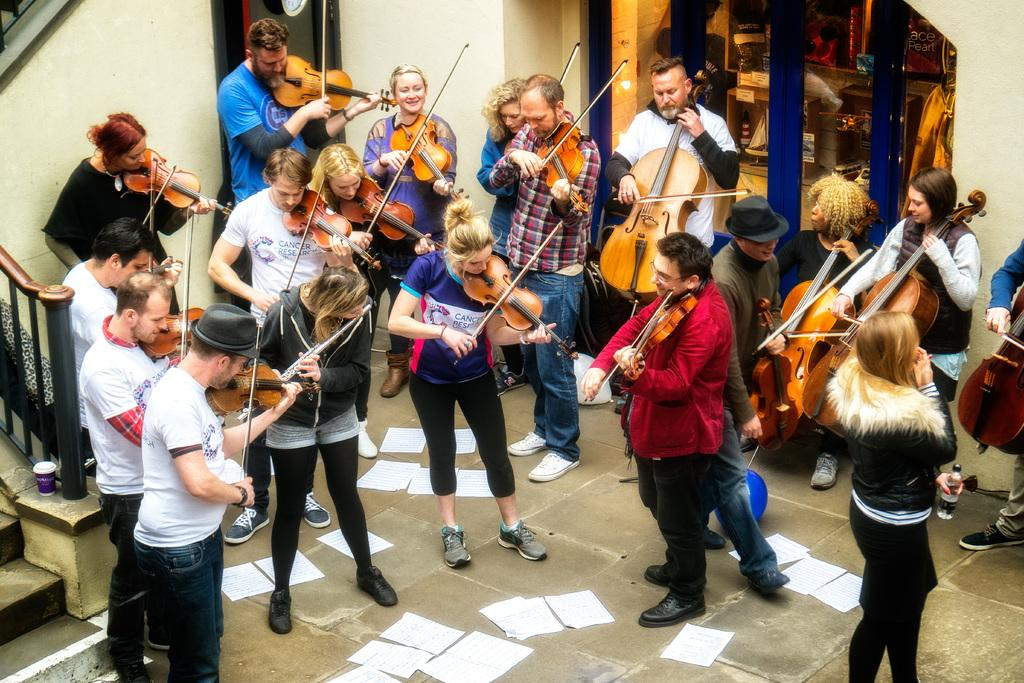What are the people in the image doing? The people in the image are playing violins. What objects are the people using to play music? The people are using violins to play music. Are there any additional items on the ground in the image? Yes, there are papers on the ground in the image. What type of sponge is being used to create a chain of peace in the image? There is no sponge or chain of peace present in the image; it features a group of people playing violins and papers on the ground. 